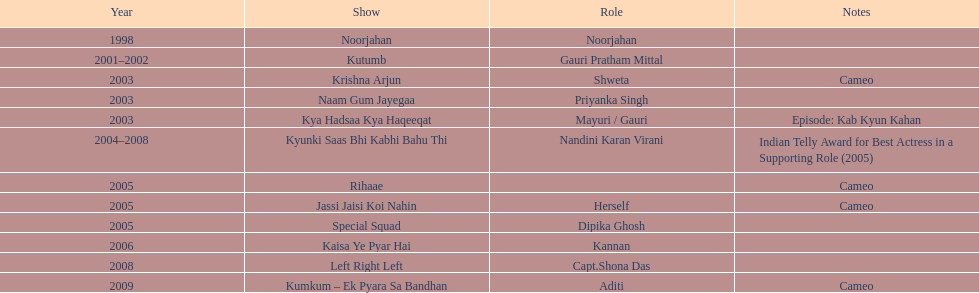Before 2000, how many unique tv shows had gauri tejwani participated in? 1. 